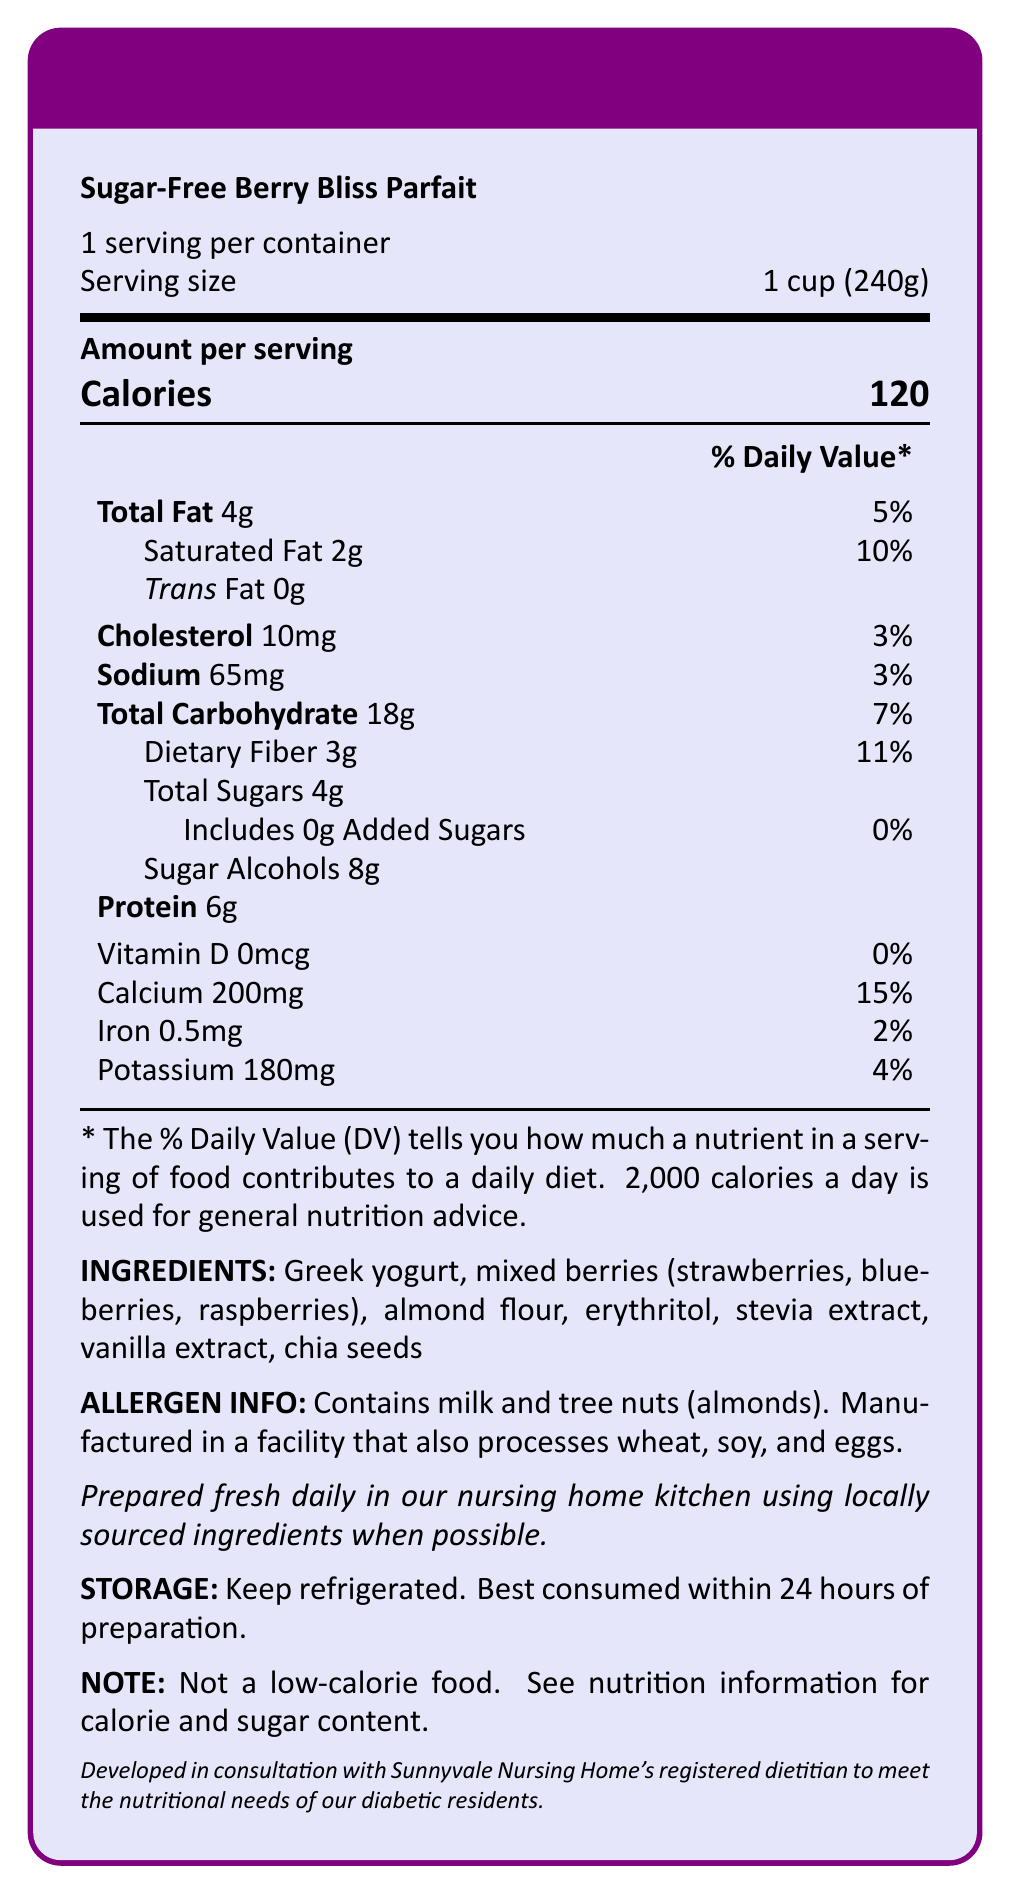what is the serving size? The document states that the serving size is 1 cup (240g).
Answer: 1 cup (240g) how many calories are there per serving? The document provides the calorie information, stating there are 120 calories per serving.
Answer: 120 calories what percentage of the daily value is the total fat content? The document mentions that the total fat content is 4g, which provides 5% of the daily value.
Answer: 5% how much dietary fiber does the dessert contain? The document lists the amount of dietary fiber as 3g per serving.
Answer: 3g does the dessert contain any added sugars? According to the document, the dessert includes 0g of added sugars.
Answer: No what are the main ingredients in the dessert? The document lists these ingredients.
Answer: Greek yogurt, mixed berries (strawberries, blueberries, raspberries), almond flour, erythritol, stevia extract, vanilla extract, chia seeds how much protein does the dessert provide? The amount of protein per serving is listed as 6g in the document.
Answer: 6g which nutrient has the highest daily value percentage? A. Calcium B. Iron C. Potassium D. Dietary Fiber Calcium has the highest daily value percentage at 15%.
Answer: A which of the following allergens are found in the dessert? I. Soy II. Wheat III. Milk IV. Tree Nuts The document states that the dessert contains milk and tree nuts (almonds).
Answer: III and IV is the dessert intended to meet the nutritional needs of diabetic residents? The document includes a note that the dessert was developed in consultation with the Sunnyvale Nursing Home's registered dietitian to meet the nutritional needs of diabetic residents.
Answer: Yes what is the sugar alcohol content? The document states that the dessert contains 8g of sugar alcohols.
Answer: 8g what are the storage instructions for the dessert? The document provides these detailed storage instructions.
Answer: Keep refrigerated. Best consumed within 24 hours of preparation. is the sugar-free berry bliss parfait a low-calorie food? The document includes a disclaimer noting that the dessert is not a low-calorie food.
Answer: No what nutrient content cannot be determined from the document? The document does not provide information about the vitamin C content.
Answer: Vitamin C summarize the main idea of the document. This summary covers all the main points and sections highlighted in the document.
Answer: The document provides the nutritional information, ingredients, allergen details, preparation and storage instructions, and a disclaimer for the Sugar-Free Berry Bliss Parfait. The dessert is developed to meet the dietary needs of diabetic residents in a nursing home. 